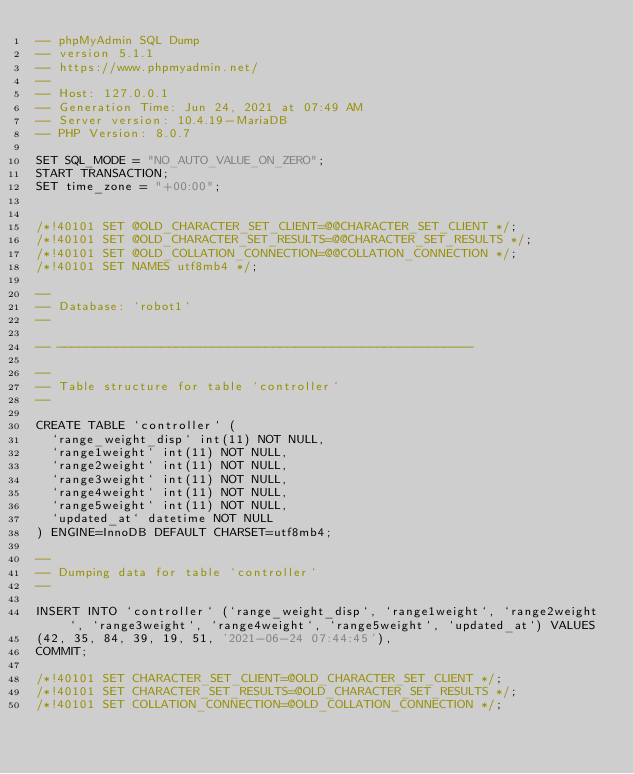Convert code to text. <code><loc_0><loc_0><loc_500><loc_500><_SQL_>-- phpMyAdmin SQL Dump
-- version 5.1.1
-- https://www.phpmyadmin.net/
--
-- Host: 127.0.0.1
-- Generation Time: Jun 24, 2021 at 07:49 AM
-- Server version: 10.4.19-MariaDB
-- PHP Version: 8.0.7

SET SQL_MODE = "NO_AUTO_VALUE_ON_ZERO";
START TRANSACTION;
SET time_zone = "+00:00";


/*!40101 SET @OLD_CHARACTER_SET_CLIENT=@@CHARACTER_SET_CLIENT */;
/*!40101 SET @OLD_CHARACTER_SET_RESULTS=@@CHARACTER_SET_RESULTS */;
/*!40101 SET @OLD_COLLATION_CONNECTION=@@COLLATION_CONNECTION */;
/*!40101 SET NAMES utf8mb4 */;

--
-- Database: `robot1`
--

-- --------------------------------------------------------

--
-- Table structure for table `controller`
--

CREATE TABLE `controller` (
  `range_weight_disp` int(11) NOT NULL,
  `range1weight` int(11) NOT NULL,
  `range2weight` int(11) NOT NULL,
  `range3weight` int(11) NOT NULL,
  `range4weight` int(11) NOT NULL,
  `range5weight` int(11) NOT NULL,
  `updated_at` datetime NOT NULL
) ENGINE=InnoDB DEFAULT CHARSET=utf8mb4;

--
-- Dumping data for table `controller`
--

INSERT INTO `controller` (`range_weight_disp`, `range1weight`, `range2weight`, `range3weight`, `range4weight`, `range5weight`, `updated_at`) VALUES
(42, 35, 84, 39, 19, 51, '2021-06-24 07:44:45'),
COMMIT;

/*!40101 SET CHARACTER_SET_CLIENT=@OLD_CHARACTER_SET_CLIENT */;
/*!40101 SET CHARACTER_SET_RESULTS=@OLD_CHARACTER_SET_RESULTS */;
/*!40101 SET COLLATION_CONNECTION=@OLD_COLLATION_CONNECTION */;
</code> 